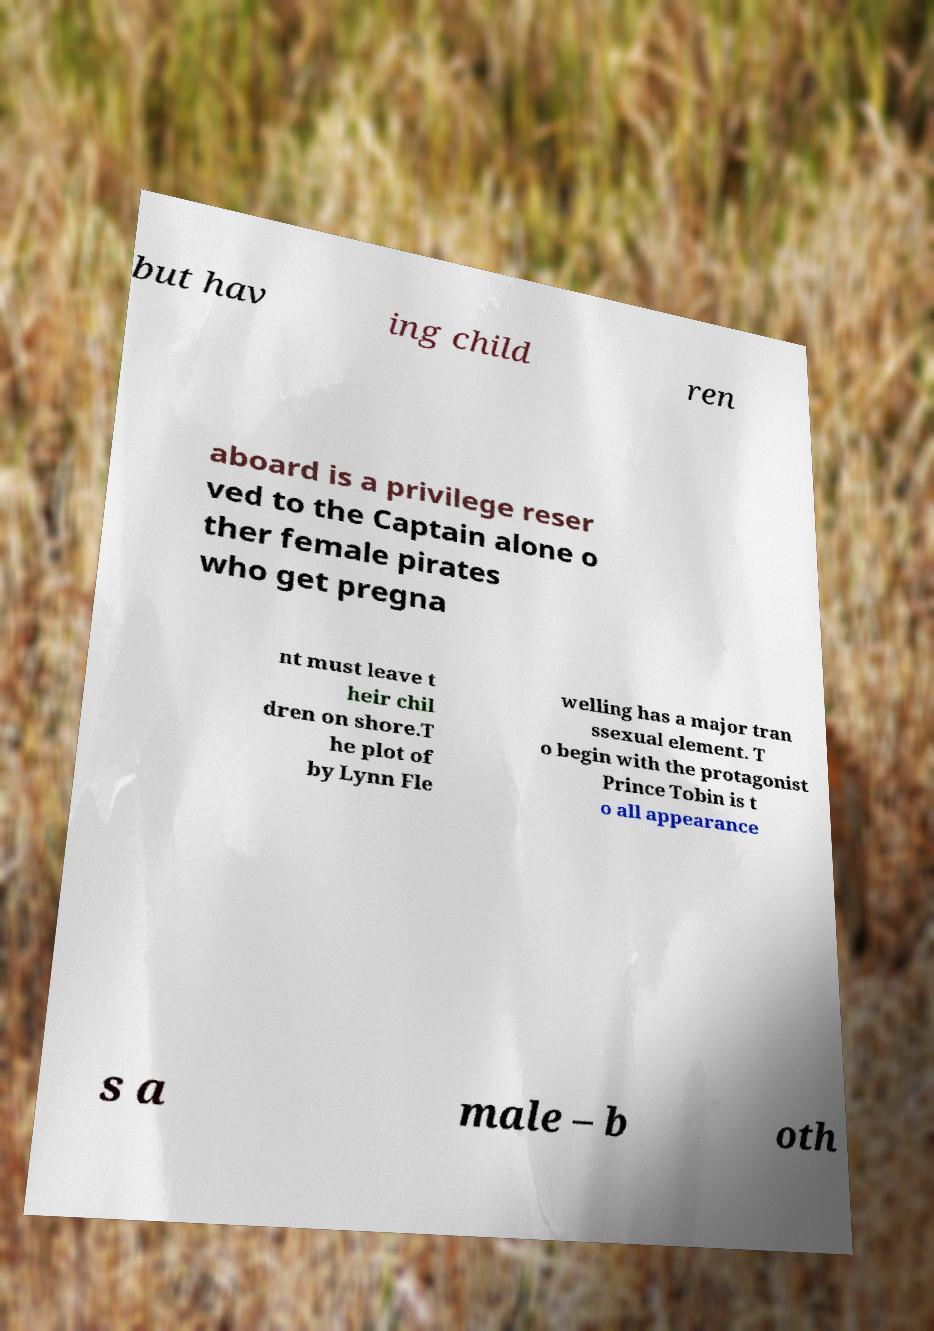Can you read and provide the text displayed in the image?This photo seems to have some interesting text. Can you extract and type it out for me? but hav ing child ren aboard is a privilege reser ved to the Captain alone o ther female pirates who get pregna nt must leave t heir chil dren on shore.T he plot of by Lynn Fle welling has a major tran ssexual element. T o begin with the protagonist Prince Tobin is t o all appearance s a male – b oth 